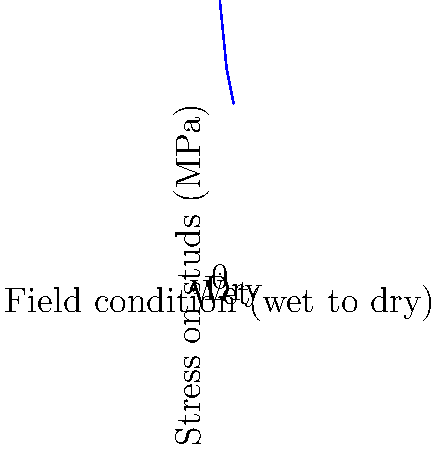Based on the graph showing stress distribution in soccer cleat studs under various field conditions, what is the approximate percentage decrease in stress when moving from the wettest to the driest condition? To calculate the percentage decrease in stress from the wettest to the driest condition:

1. Identify stress values:
   - Wettest condition (x = 0): 80 MPa
   - Driest condition (x = 4): 50 MPa

2. Calculate the difference:
   $\Delta \text{Stress} = 80 \text{ MPa} - 50 \text{ MPa} = 30 \text{ MPa}$

3. Calculate the percentage decrease:
   $\text{Percentage decrease} = \frac{\Delta \text{Stress}}{\text{Initial Stress}} \times 100\%$
   $= \frac{30 \text{ MPa}}{80 \text{ MPa}} \times 100\%$
   $= 0.375 \times 100\%$
   $= 37.5\%$

Therefore, the approximate percentage decrease in stress when moving from the wettest to the driest condition is 37.5%.
Answer: 37.5% 